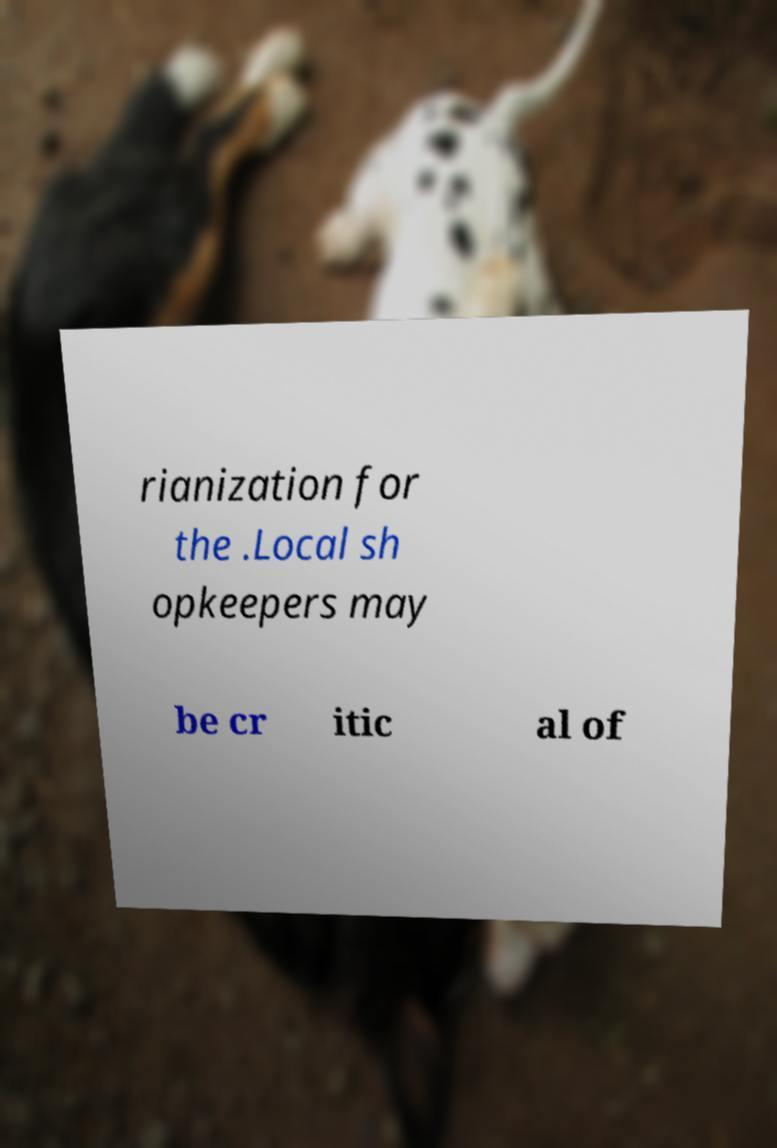I need the written content from this picture converted into text. Can you do that? rianization for the .Local sh opkeepers may be cr itic al of 